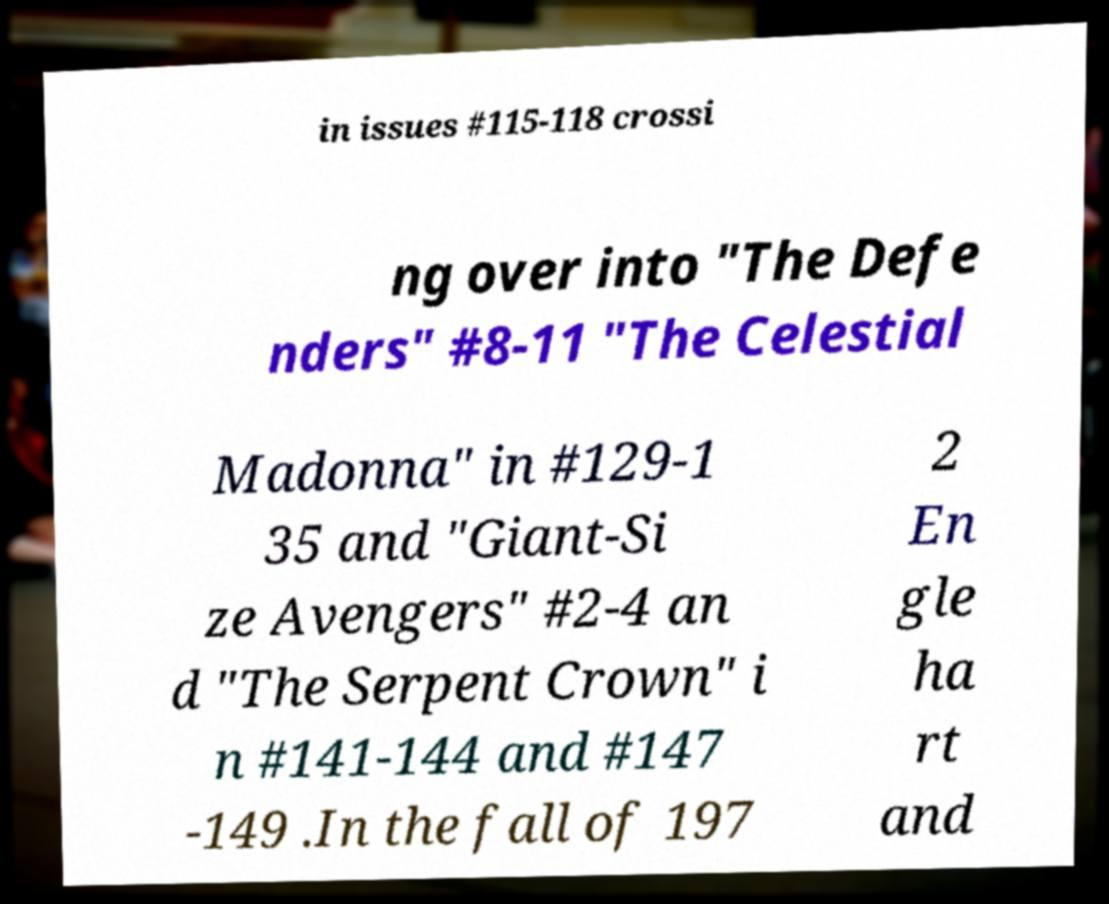Could you extract and type out the text from this image? in issues #115-118 crossi ng over into "The Defe nders" #8-11 "The Celestial Madonna" in #129-1 35 and "Giant-Si ze Avengers" #2-4 an d "The Serpent Crown" i n #141-144 and #147 -149 .In the fall of 197 2 En gle ha rt and 